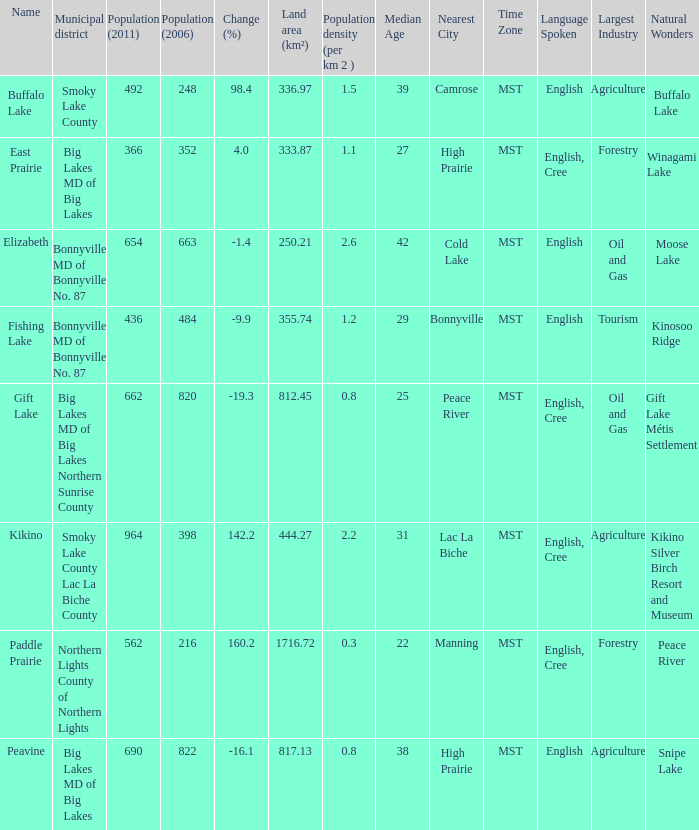What is the density per km in Smoky Lake County? 1.5. 